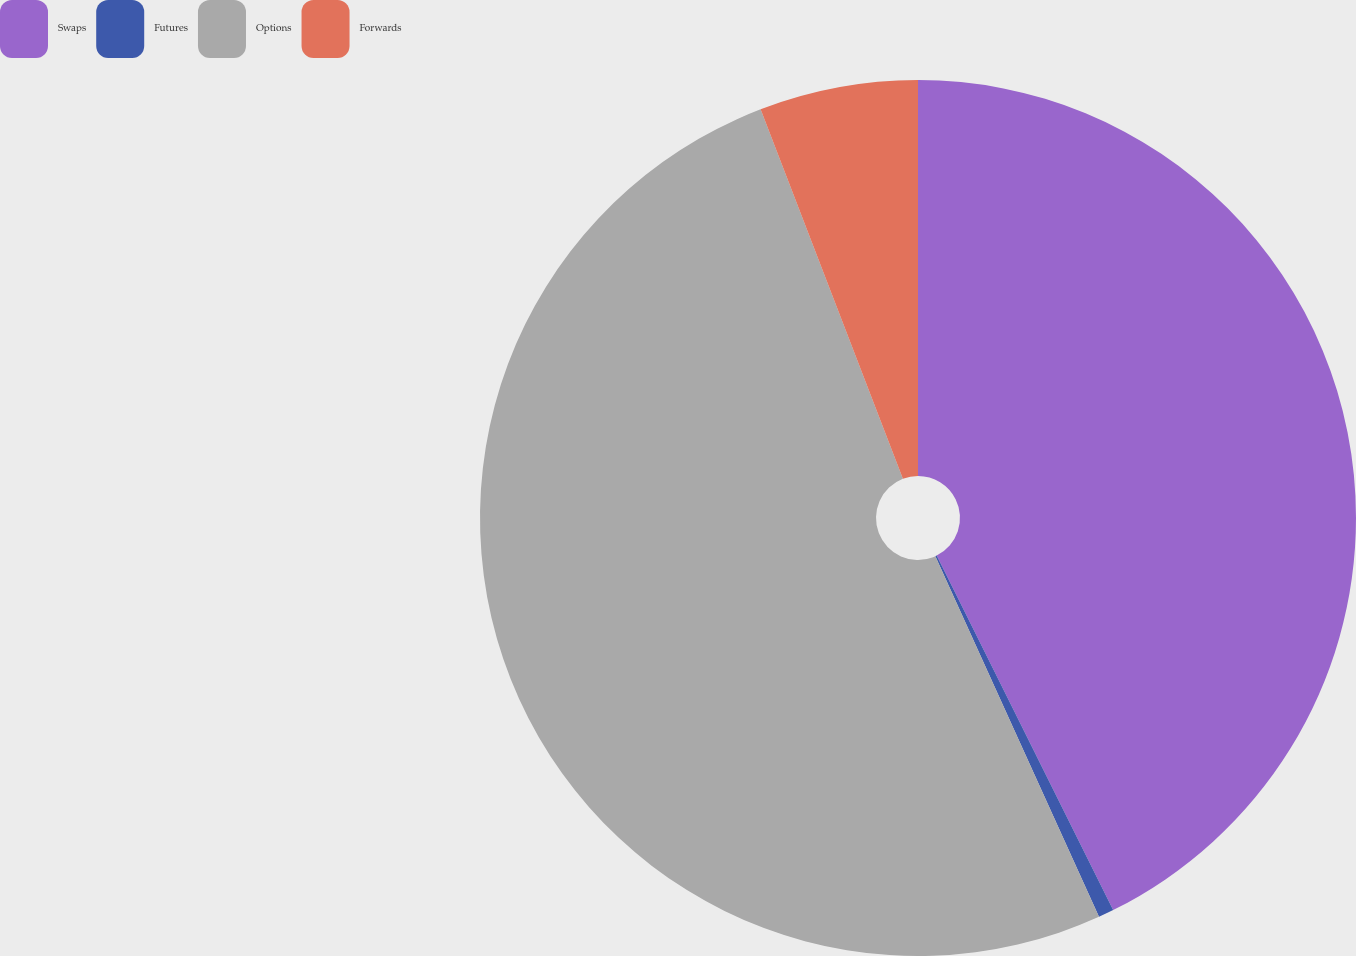Convert chart. <chart><loc_0><loc_0><loc_500><loc_500><pie_chart><fcel>Swaps<fcel>Futures<fcel>Options<fcel>Forwards<nl><fcel>42.65%<fcel>0.57%<fcel>50.93%<fcel>5.85%<nl></chart> 